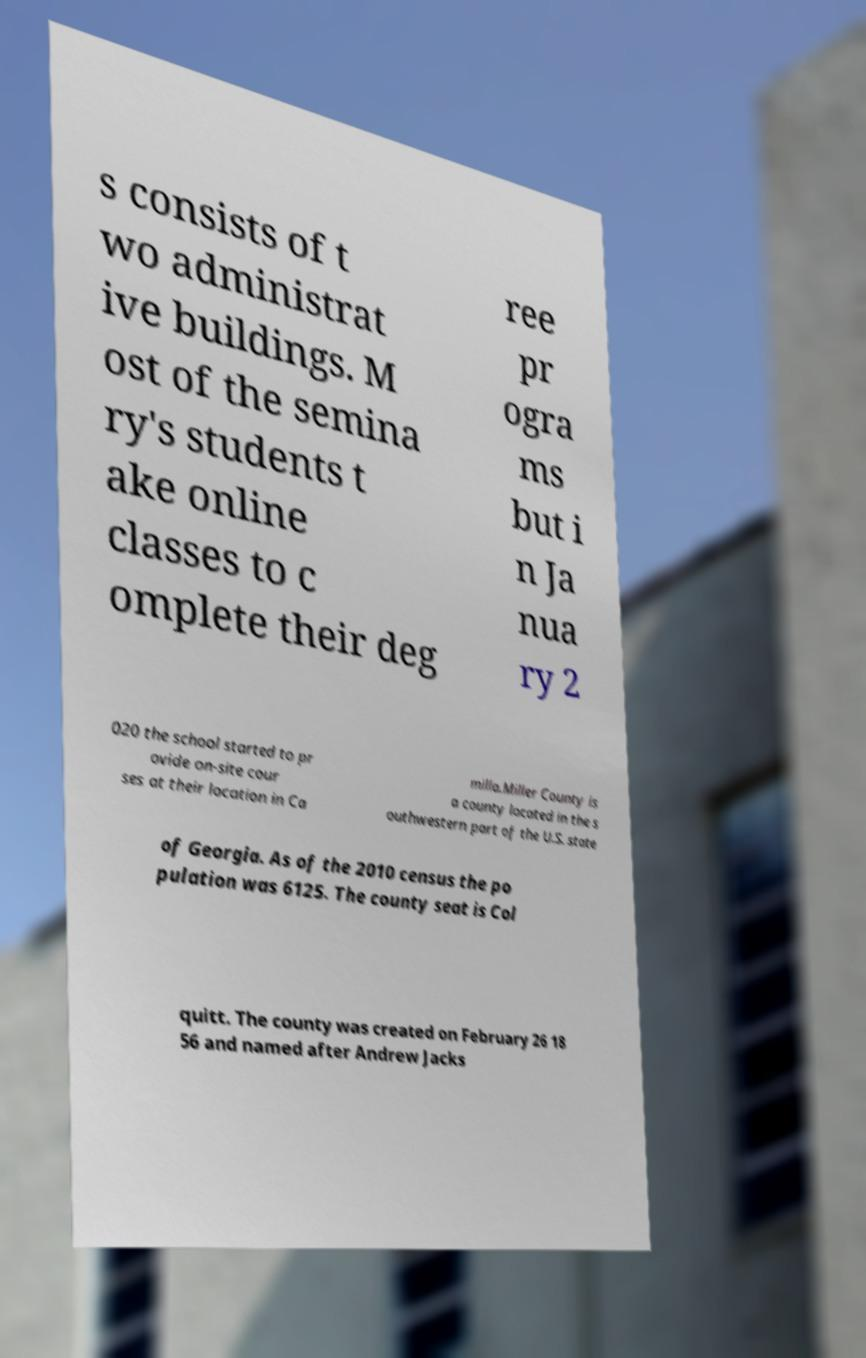Can you read and provide the text displayed in the image?This photo seems to have some interesting text. Can you extract and type it out for me? s consists of t wo administrat ive buildings. M ost of the semina ry's students t ake online classes to c omplete their deg ree pr ogra ms but i n Ja nua ry 2 020 the school started to pr ovide on-site cour ses at their location in Ca milla.Miller County is a county located in the s outhwestern part of the U.S. state of Georgia. As of the 2010 census the po pulation was 6125. The county seat is Col quitt. The county was created on February 26 18 56 and named after Andrew Jacks 